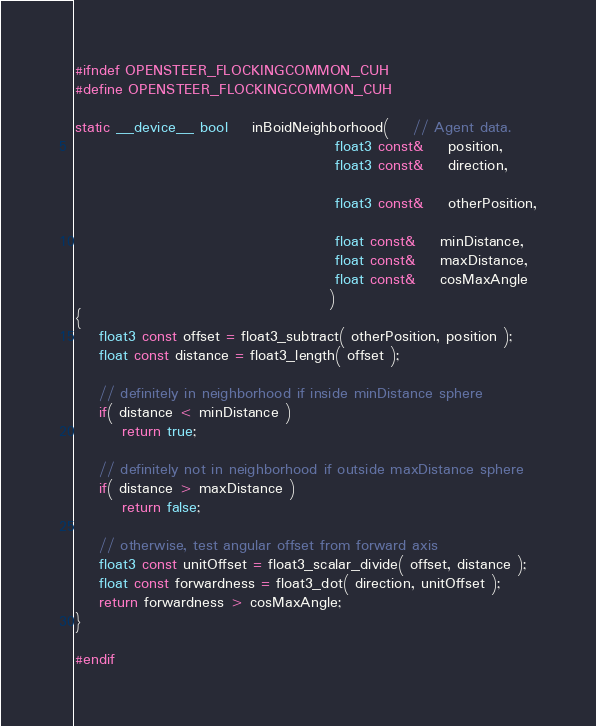Convert code to text. <code><loc_0><loc_0><loc_500><loc_500><_Cuda_>#ifndef OPENSTEER_FLOCKINGCOMMON_CUH
#define OPENSTEER_FLOCKINGCOMMON_CUH

static __device__ bool	inBoidNeighborhood(	// Agent data.
											float3 const&	position,
											float3 const&	direction,

											float3 const&	otherPosition,

											float const&	minDistance,
											float const&	maxDistance,
											float const&	cosMaxAngle
										   )
{
	float3 const offset = float3_subtract( otherPosition, position );
	float const distance = float3_length( offset );

	// definitely in neighborhood if inside minDistance sphere
	if( distance < minDistance )
		return true;

	// definitely not in neighborhood if outside maxDistance sphere
	if( distance > maxDistance )
		return false;

	// otherwise, test angular offset from forward axis
	float3 const unitOffset = float3_scalar_divide( offset, distance );
	float const forwardness = float3_dot( direction, unitOffset );
	return forwardness > cosMaxAngle;
}

#endif
</code> 